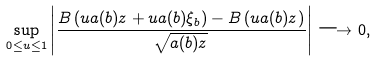Convert formula to latex. <formula><loc_0><loc_0><loc_500><loc_500>\sup _ { 0 \leq u \leq 1 } \left | \frac { B \left ( u a ( b ) z + u a ( b ) \xi _ { b } \right ) - B \left ( u a ( b ) z \right ) } { \sqrt { a ( b ) z } } \right | \longrightarrow 0 ,</formula> 